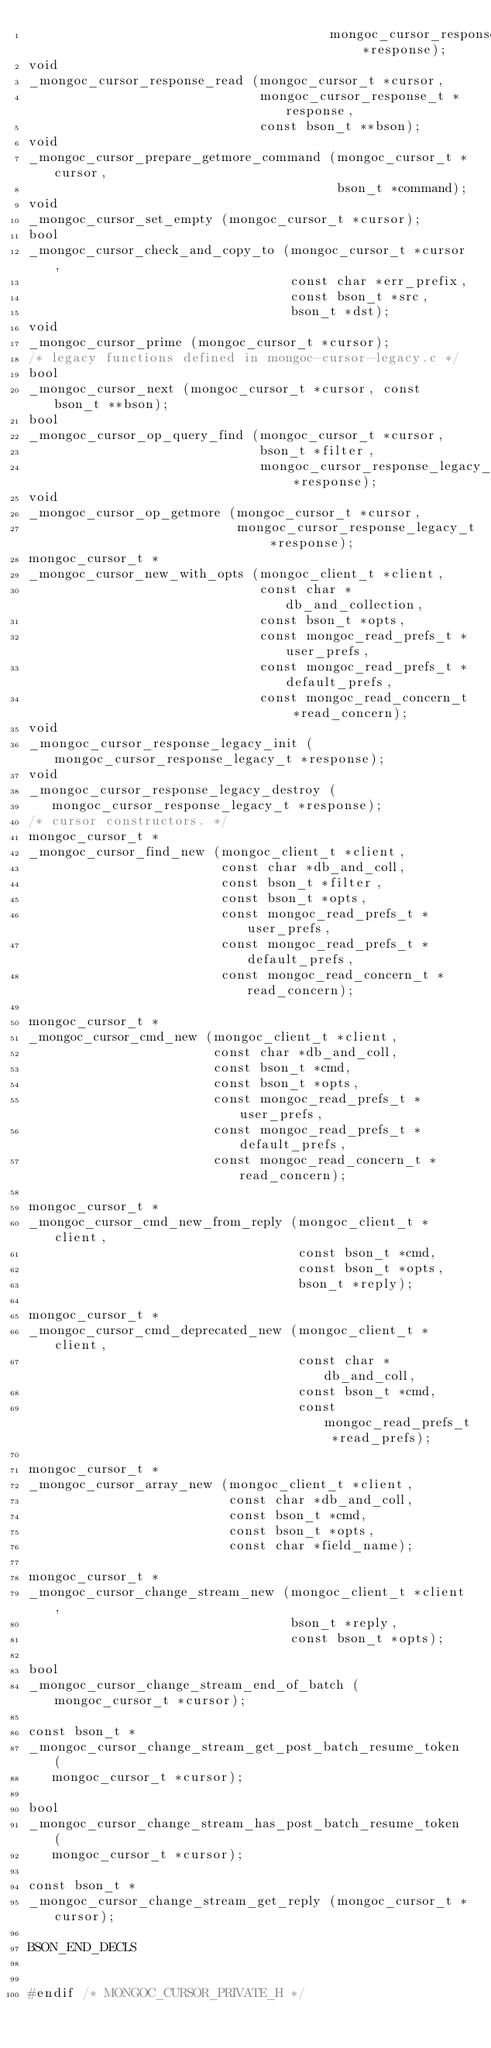Convert code to text. <code><loc_0><loc_0><loc_500><loc_500><_C_>                                       mongoc_cursor_response_t *response);
void
_mongoc_cursor_response_read (mongoc_cursor_t *cursor,
                              mongoc_cursor_response_t *response,
                              const bson_t **bson);
void
_mongoc_cursor_prepare_getmore_command (mongoc_cursor_t *cursor,
                                        bson_t *command);
void
_mongoc_cursor_set_empty (mongoc_cursor_t *cursor);
bool
_mongoc_cursor_check_and_copy_to (mongoc_cursor_t *cursor,
                                  const char *err_prefix,
                                  const bson_t *src,
                                  bson_t *dst);
void
_mongoc_cursor_prime (mongoc_cursor_t *cursor);
/* legacy functions defined in mongoc-cursor-legacy.c */
bool
_mongoc_cursor_next (mongoc_cursor_t *cursor, const bson_t **bson);
bool
_mongoc_cursor_op_query_find (mongoc_cursor_t *cursor,
                              bson_t *filter,
                              mongoc_cursor_response_legacy_t *response);
void
_mongoc_cursor_op_getmore (mongoc_cursor_t *cursor,
                           mongoc_cursor_response_legacy_t *response);
mongoc_cursor_t *
_mongoc_cursor_new_with_opts (mongoc_client_t *client,
                              const char *db_and_collection,
                              const bson_t *opts,
                              const mongoc_read_prefs_t *user_prefs,
                              const mongoc_read_prefs_t *default_prefs,
                              const mongoc_read_concern_t *read_concern);
void
_mongoc_cursor_response_legacy_init (mongoc_cursor_response_legacy_t *response);
void
_mongoc_cursor_response_legacy_destroy (
   mongoc_cursor_response_legacy_t *response);
/* cursor constructors. */
mongoc_cursor_t *
_mongoc_cursor_find_new (mongoc_client_t *client,
                         const char *db_and_coll,
                         const bson_t *filter,
                         const bson_t *opts,
                         const mongoc_read_prefs_t *user_prefs,
                         const mongoc_read_prefs_t *default_prefs,
                         const mongoc_read_concern_t *read_concern);

mongoc_cursor_t *
_mongoc_cursor_cmd_new (mongoc_client_t *client,
                        const char *db_and_coll,
                        const bson_t *cmd,
                        const bson_t *opts,
                        const mongoc_read_prefs_t *user_prefs,
                        const mongoc_read_prefs_t *default_prefs,
                        const mongoc_read_concern_t *read_concern);

mongoc_cursor_t *
_mongoc_cursor_cmd_new_from_reply (mongoc_client_t *client,
                                   const bson_t *cmd,
                                   const bson_t *opts,
                                   bson_t *reply);

mongoc_cursor_t *
_mongoc_cursor_cmd_deprecated_new (mongoc_client_t *client,
                                   const char *db_and_coll,
                                   const bson_t *cmd,
                                   const mongoc_read_prefs_t *read_prefs);

mongoc_cursor_t *
_mongoc_cursor_array_new (mongoc_client_t *client,
                          const char *db_and_coll,
                          const bson_t *cmd,
                          const bson_t *opts,
                          const char *field_name);

mongoc_cursor_t *
_mongoc_cursor_change_stream_new (mongoc_client_t *client,
                                  bson_t *reply,
                                  const bson_t *opts);

bool
_mongoc_cursor_change_stream_end_of_batch (mongoc_cursor_t *cursor);

const bson_t *
_mongoc_cursor_change_stream_get_post_batch_resume_token (
   mongoc_cursor_t *cursor);

bool
_mongoc_cursor_change_stream_has_post_batch_resume_token (
   mongoc_cursor_t *cursor);

const bson_t *
_mongoc_cursor_change_stream_get_reply (mongoc_cursor_t *cursor);

BSON_END_DECLS


#endif /* MONGOC_CURSOR_PRIVATE_H */
</code> 